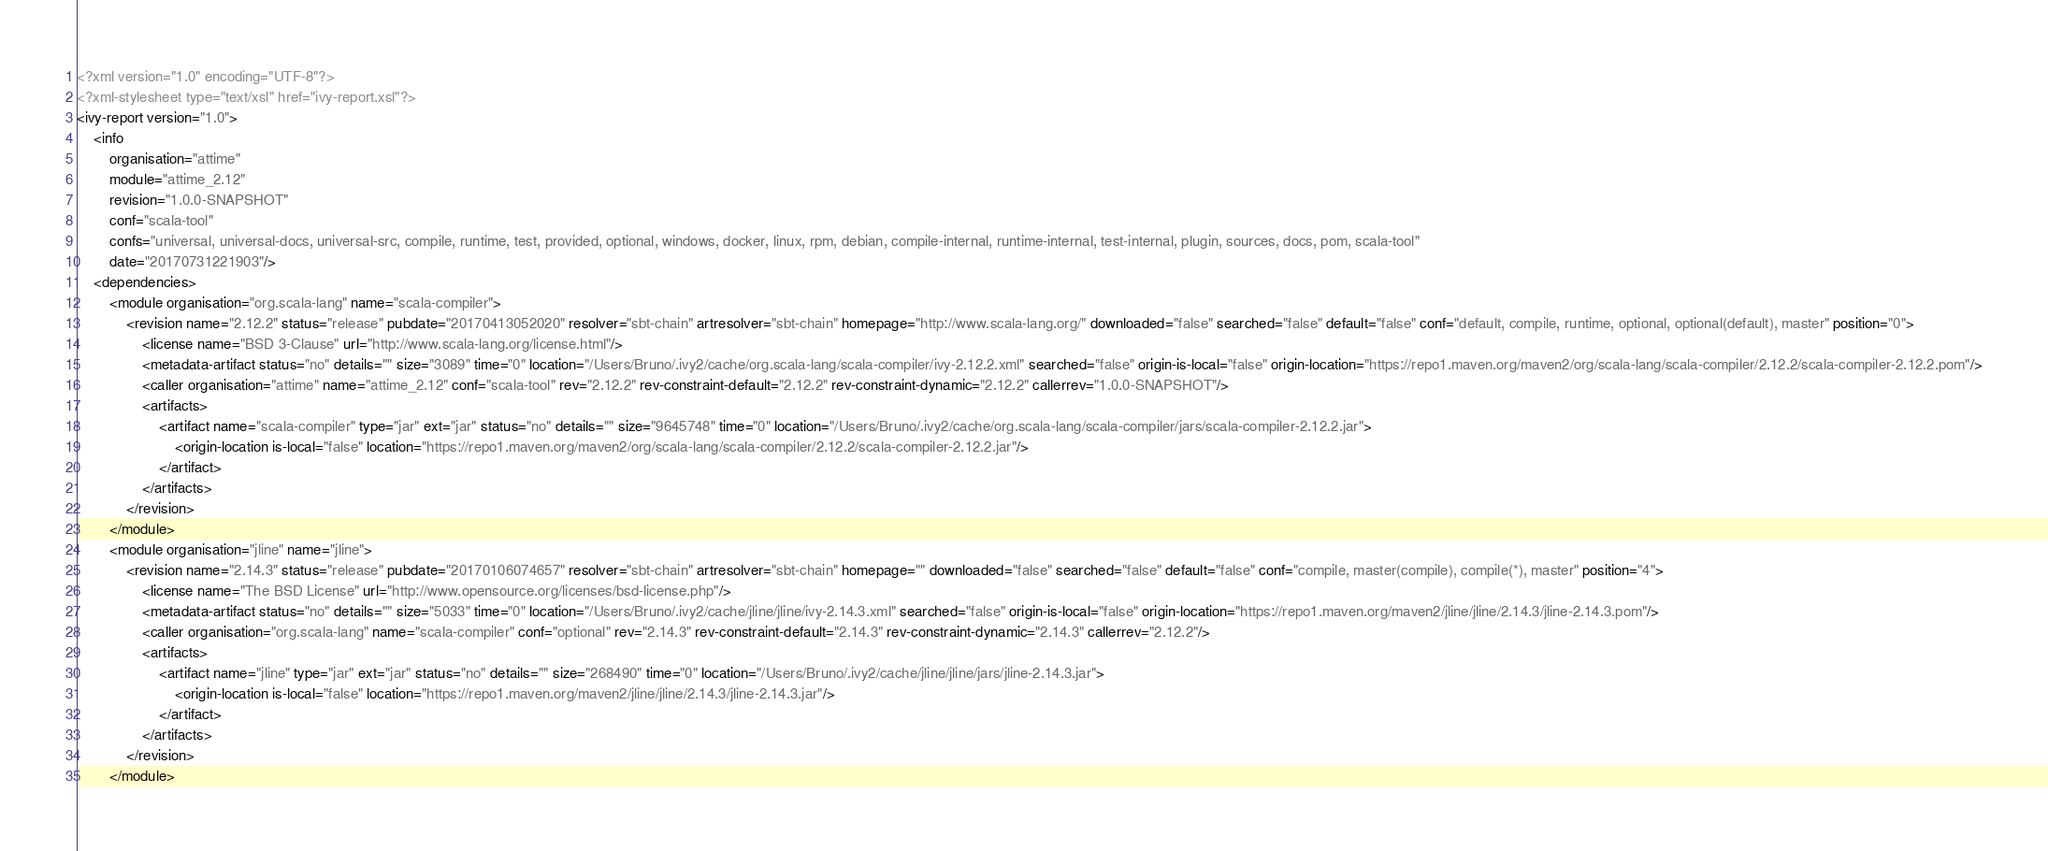Convert code to text. <code><loc_0><loc_0><loc_500><loc_500><_XML_><?xml version="1.0" encoding="UTF-8"?>
<?xml-stylesheet type="text/xsl" href="ivy-report.xsl"?>
<ivy-report version="1.0">
	<info
		organisation="attime"
		module="attime_2.12"
		revision="1.0.0-SNAPSHOT"
		conf="scala-tool"
		confs="universal, universal-docs, universal-src, compile, runtime, test, provided, optional, windows, docker, linux, rpm, debian, compile-internal, runtime-internal, test-internal, plugin, sources, docs, pom, scala-tool"
		date="20170731221903"/>
	<dependencies>
		<module organisation="org.scala-lang" name="scala-compiler">
			<revision name="2.12.2" status="release" pubdate="20170413052020" resolver="sbt-chain" artresolver="sbt-chain" homepage="http://www.scala-lang.org/" downloaded="false" searched="false" default="false" conf="default, compile, runtime, optional, optional(default), master" position="0">
				<license name="BSD 3-Clause" url="http://www.scala-lang.org/license.html"/>
				<metadata-artifact status="no" details="" size="3089" time="0" location="/Users/Bruno/.ivy2/cache/org.scala-lang/scala-compiler/ivy-2.12.2.xml" searched="false" origin-is-local="false" origin-location="https://repo1.maven.org/maven2/org/scala-lang/scala-compiler/2.12.2/scala-compiler-2.12.2.pom"/>
				<caller organisation="attime" name="attime_2.12" conf="scala-tool" rev="2.12.2" rev-constraint-default="2.12.2" rev-constraint-dynamic="2.12.2" callerrev="1.0.0-SNAPSHOT"/>
				<artifacts>
					<artifact name="scala-compiler" type="jar" ext="jar" status="no" details="" size="9645748" time="0" location="/Users/Bruno/.ivy2/cache/org.scala-lang/scala-compiler/jars/scala-compiler-2.12.2.jar">
						<origin-location is-local="false" location="https://repo1.maven.org/maven2/org/scala-lang/scala-compiler/2.12.2/scala-compiler-2.12.2.jar"/>
					</artifact>
				</artifacts>
			</revision>
		</module>
		<module organisation="jline" name="jline">
			<revision name="2.14.3" status="release" pubdate="20170106074657" resolver="sbt-chain" artresolver="sbt-chain" homepage="" downloaded="false" searched="false" default="false" conf="compile, master(compile), compile(*), master" position="4">
				<license name="The BSD License" url="http://www.opensource.org/licenses/bsd-license.php"/>
				<metadata-artifact status="no" details="" size="5033" time="0" location="/Users/Bruno/.ivy2/cache/jline/jline/ivy-2.14.3.xml" searched="false" origin-is-local="false" origin-location="https://repo1.maven.org/maven2/jline/jline/2.14.3/jline-2.14.3.pom"/>
				<caller organisation="org.scala-lang" name="scala-compiler" conf="optional" rev="2.14.3" rev-constraint-default="2.14.3" rev-constraint-dynamic="2.14.3" callerrev="2.12.2"/>
				<artifacts>
					<artifact name="jline" type="jar" ext="jar" status="no" details="" size="268490" time="0" location="/Users/Bruno/.ivy2/cache/jline/jline/jars/jline-2.14.3.jar">
						<origin-location is-local="false" location="https://repo1.maven.org/maven2/jline/jline/2.14.3/jline-2.14.3.jar"/>
					</artifact>
				</artifacts>
			</revision>
		</module></code> 